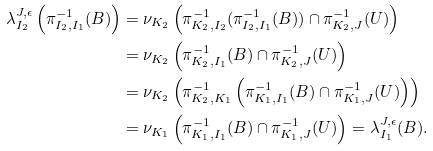<formula> <loc_0><loc_0><loc_500><loc_500>\lambda _ { I _ { 2 } } ^ { J , \epsilon } \left ( \pi _ { I _ { 2 } , I _ { 1 } } ^ { - 1 } ( B ) \right ) & = \nu _ { K _ { 2 } } \left ( \pi ^ { - 1 } _ { K _ { 2 } , I _ { 2 } } ( \pi _ { I _ { 2 } , I _ { 1 } } ^ { - 1 } ( B ) ) \cap \pi ^ { - 1 } _ { K _ { 2 } , J } ( U ) \right ) \\ & = \nu _ { K _ { 2 } } \left ( \pi ^ { - 1 } _ { K _ { 2 } , I _ { 1 } } ( B ) \cap \pi ^ { - 1 } _ { K _ { 2 } , J } ( U ) \right ) \\ & = \nu _ { K _ { 2 } } \left ( \pi ^ { - 1 } _ { K _ { 2 } , K _ { 1 } } \left ( \pi _ { K _ { 1 } , I _ { 1 } } ^ { - 1 } ( B ) \cap \pi ^ { - 1 } _ { K _ { 1 } , J } ( U ) \right ) \right ) \\ & = \nu _ { K _ { 1 } } \left ( \pi _ { K _ { 1 } , I _ { 1 } } ^ { - 1 } ( B ) \cap \pi ^ { - 1 } _ { K _ { 1 } , J } ( U ) \right ) = \lambda _ { I _ { 1 } } ^ { J , \epsilon } ( B ) .</formula> 